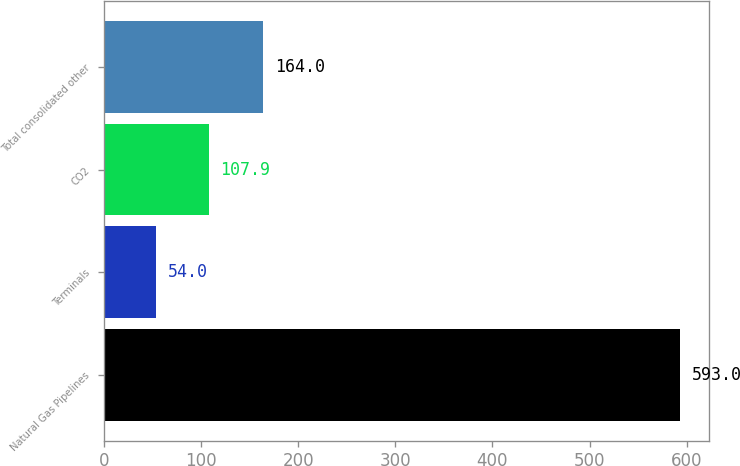Convert chart to OTSL. <chart><loc_0><loc_0><loc_500><loc_500><bar_chart><fcel>Natural Gas Pipelines<fcel>Terminals<fcel>CO2<fcel>Total consolidated other<nl><fcel>593<fcel>54<fcel>107.9<fcel>164<nl></chart> 